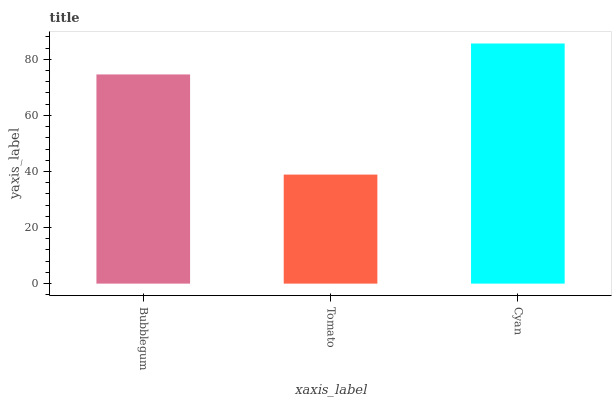Is Tomato the minimum?
Answer yes or no. Yes. Is Cyan the maximum?
Answer yes or no. Yes. Is Cyan the minimum?
Answer yes or no. No. Is Tomato the maximum?
Answer yes or no. No. Is Cyan greater than Tomato?
Answer yes or no. Yes. Is Tomato less than Cyan?
Answer yes or no. Yes. Is Tomato greater than Cyan?
Answer yes or no. No. Is Cyan less than Tomato?
Answer yes or no. No. Is Bubblegum the high median?
Answer yes or no. Yes. Is Bubblegum the low median?
Answer yes or no. Yes. Is Tomato the high median?
Answer yes or no. No. Is Cyan the low median?
Answer yes or no. No. 